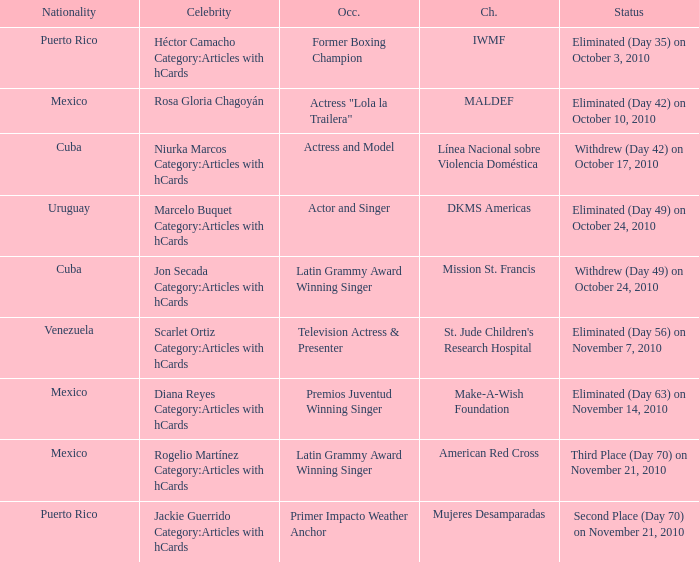What is the charity for the celebrity with an occupation title of actor and singer? DKMS Americas. 